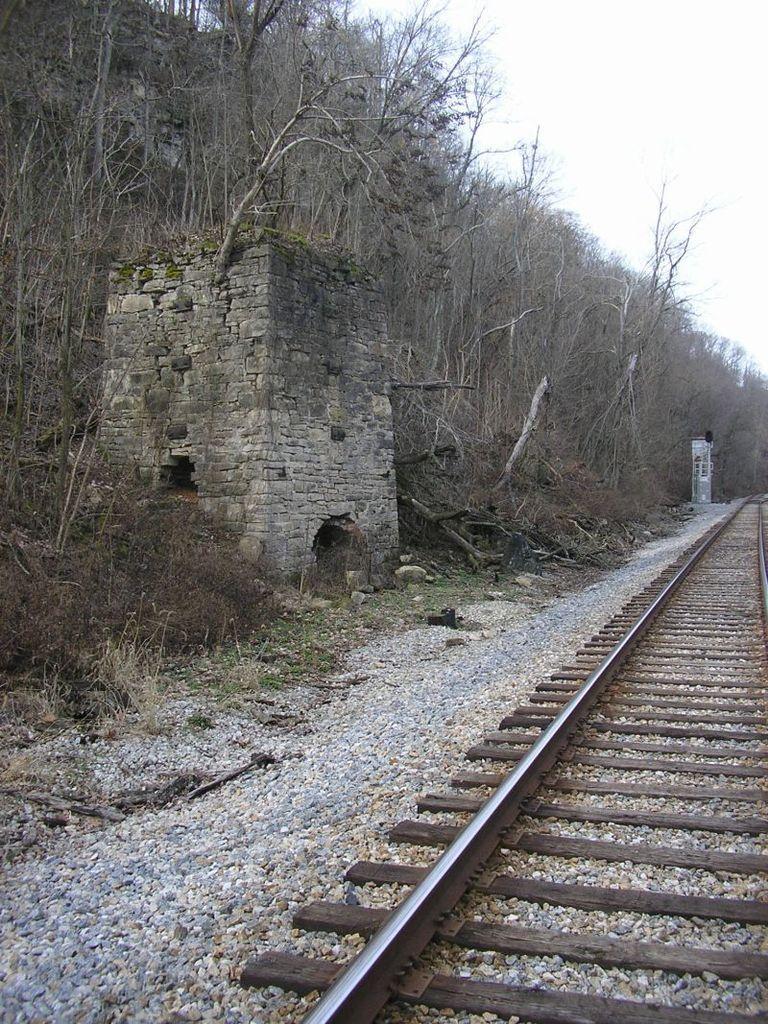Describe this image in one or two sentences. In this image, we can see a fort, pole and trees. At the bottom, there is track and we can see stones. 